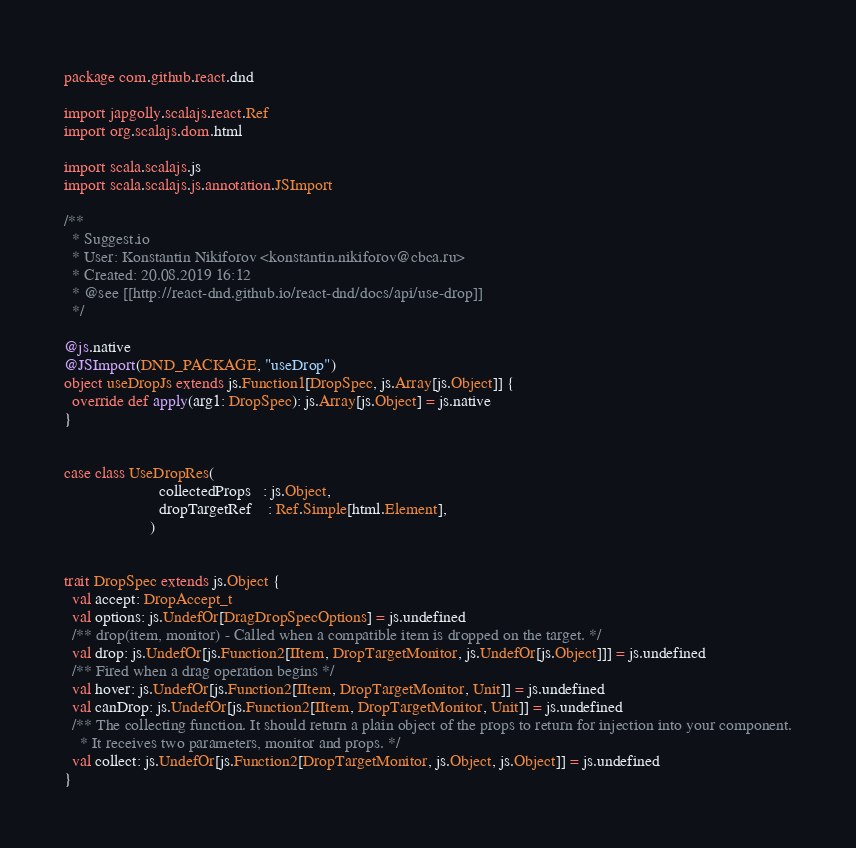Convert code to text. <code><loc_0><loc_0><loc_500><loc_500><_Scala_>package com.github.react.dnd

import japgolly.scalajs.react.Ref
import org.scalajs.dom.html

import scala.scalajs.js
import scala.scalajs.js.annotation.JSImport

/**
  * Suggest.io
  * User: Konstantin Nikiforov <konstantin.nikiforov@cbca.ru>
  * Created: 20.08.2019 16:12
  * @see [[http://react-dnd.github.io/react-dnd/docs/api/use-drop]]
  */

@js.native
@JSImport(DND_PACKAGE, "useDrop")
object useDropJs extends js.Function1[DropSpec, js.Array[js.Object]] {
  override def apply(arg1: DropSpec): js.Array[js.Object] = js.native
}


case class UseDropRes(
                       collectedProps   : js.Object,
                       dropTargetRef    : Ref.Simple[html.Element],
                     )


trait DropSpec extends js.Object {
  val accept: DropAccept_t
  val options: js.UndefOr[DragDropSpecOptions] = js.undefined
  /** drop(item, monitor) - Called when a compatible item is dropped on the target. */
  val drop: js.UndefOr[js.Function2[IItem, DropTargetMonitor, js.UndefOr[js.Object]]] = js.undefined
  /** Fired when a drag operation begins */
  val hover: js.UndefOr[js.Function2[IItem, DropTargetMonitor, Unit]] = js.undefined
  val canDrop: js.UndefOr[js.Function2[IItem, DropTargetMonitor, Unit]] = js.undefined
  /** The collecting function. It should return a plain object of the props to return for injection into your component.
    * It receives two parameters, monitor and props. */
  val collect: js.UndefOr[js.Function2[DropTargetMonitor, js.Object, js.Object]] = js.undefined
}

</code> 